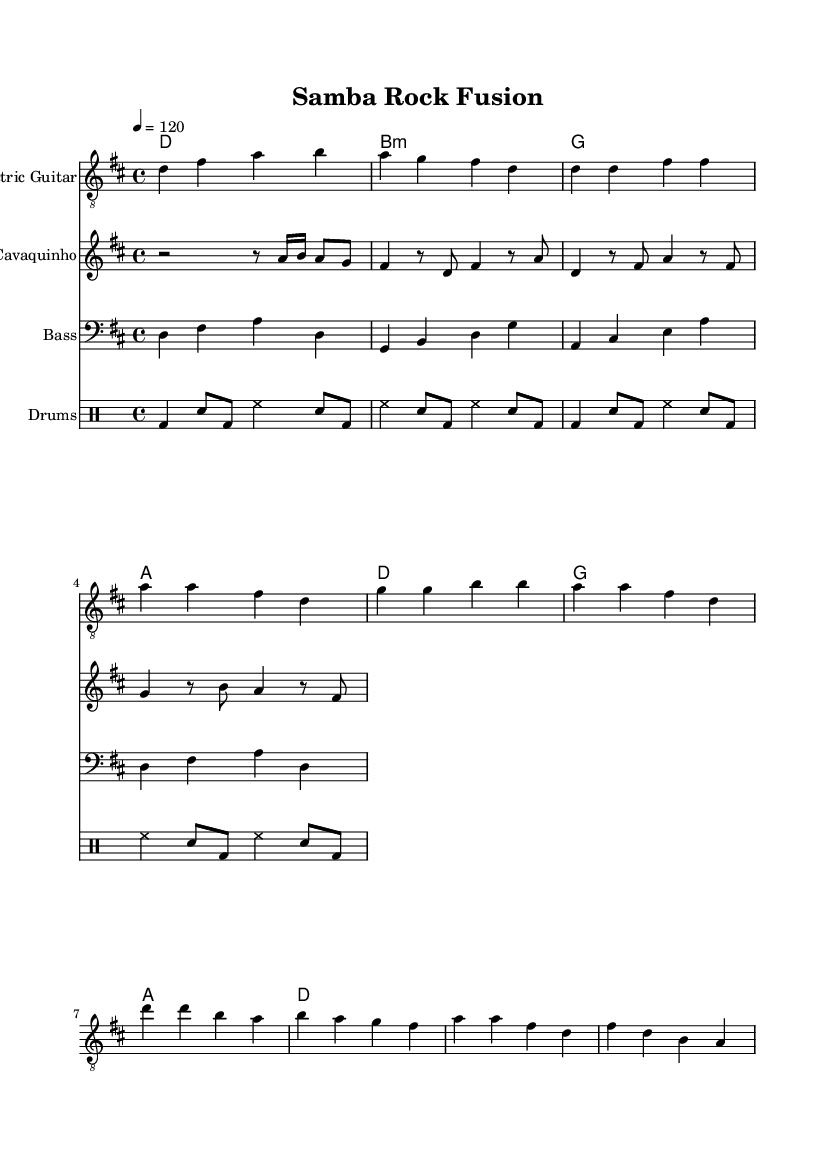What is the key signature of this music? The key signature shown at the beginning of the score indicates D major, which has two sharps: F# and C#.
Answer: D major What is the time signature used in the piece? The time signature presented at the beginning is 4/4, which means there are four beats per measure and the quarter note receives one beat.
Answer: 4/4 What is the tempo marking for this piece? The tempo is indicated at the beginning of the score as 120 beats per minute, meaning the music should be played at a moderate pace.
Answer: 120 How many measures are in the electric guitar section? Counting the measures in the electric guitar part reveals that there are a total of 8 measures in this section.
Answer: 8 Which instruments are used in this fusion piece? The instruments listed in the score include electric guitar, cavaquinho, bass, and drums, highlighting the combination of Brazilian and British music styles.
Answer: Electric guitar, cavaquinho, bass, drums In what form is the harmony of the piece primarily structured? The harmony is structured using chord symbols above the staves, which indicate a pattern of chords that accompany the melody, showing typical rock progressions.
Answer: Chord symbols What is a characteristic rhythmic feature found in the drums? The drum part includes a consistent bass drum and snare pattern, common in rock music, which helps to create a driving rhythm throughout the piece.
Answer: Bass and snare pattern 